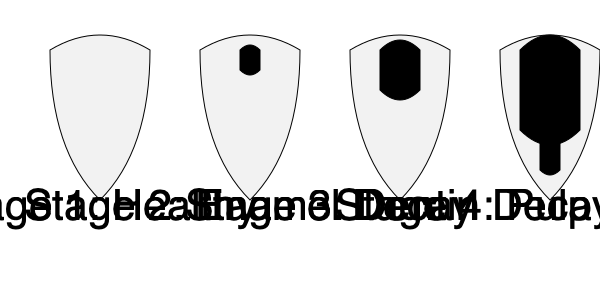As a violinist who frequently experiences dental issues, you're familiar with the stages of tooth decay. Based on the cross-sectional images provided, at which stage does the decay begin to affect the dentin layer of the tooth? To answer this question, let's analyze the stages of tooth decay shown in the images:

1. Stage 1 (Healthy): The tooth appears intact with no visible decay.

2. Stage 2 (Enamel Decay): A small brown area is visible on the tooth's surface, indicating the beginning of decay in the enamel layer.

3. Stage 3 (Dentin Decay): The decay has progressed deeper into the tooth, reaching the dentin layer. This is evident from the larger brown area extending further into the tooth structure.

4. Stage 4 (Pulp Infection): The decay has reached the innermost part of the tooth, affecting the pulp. This is shown by the red area in the center of the tooth.

The question asks at which stage the decay begins to affect the dentin layer. By examining the images, we can see that this occurs in Stage 3, where the decay extends beyond the enamel and into the dentin.

As a violinist, understanding this progression is crucial, as the pressure and vibrations from playing the instrument can accelerate tooth wear and potentially exacerbate decay if proper dental care is not maintained.
Answer: Stage 3 